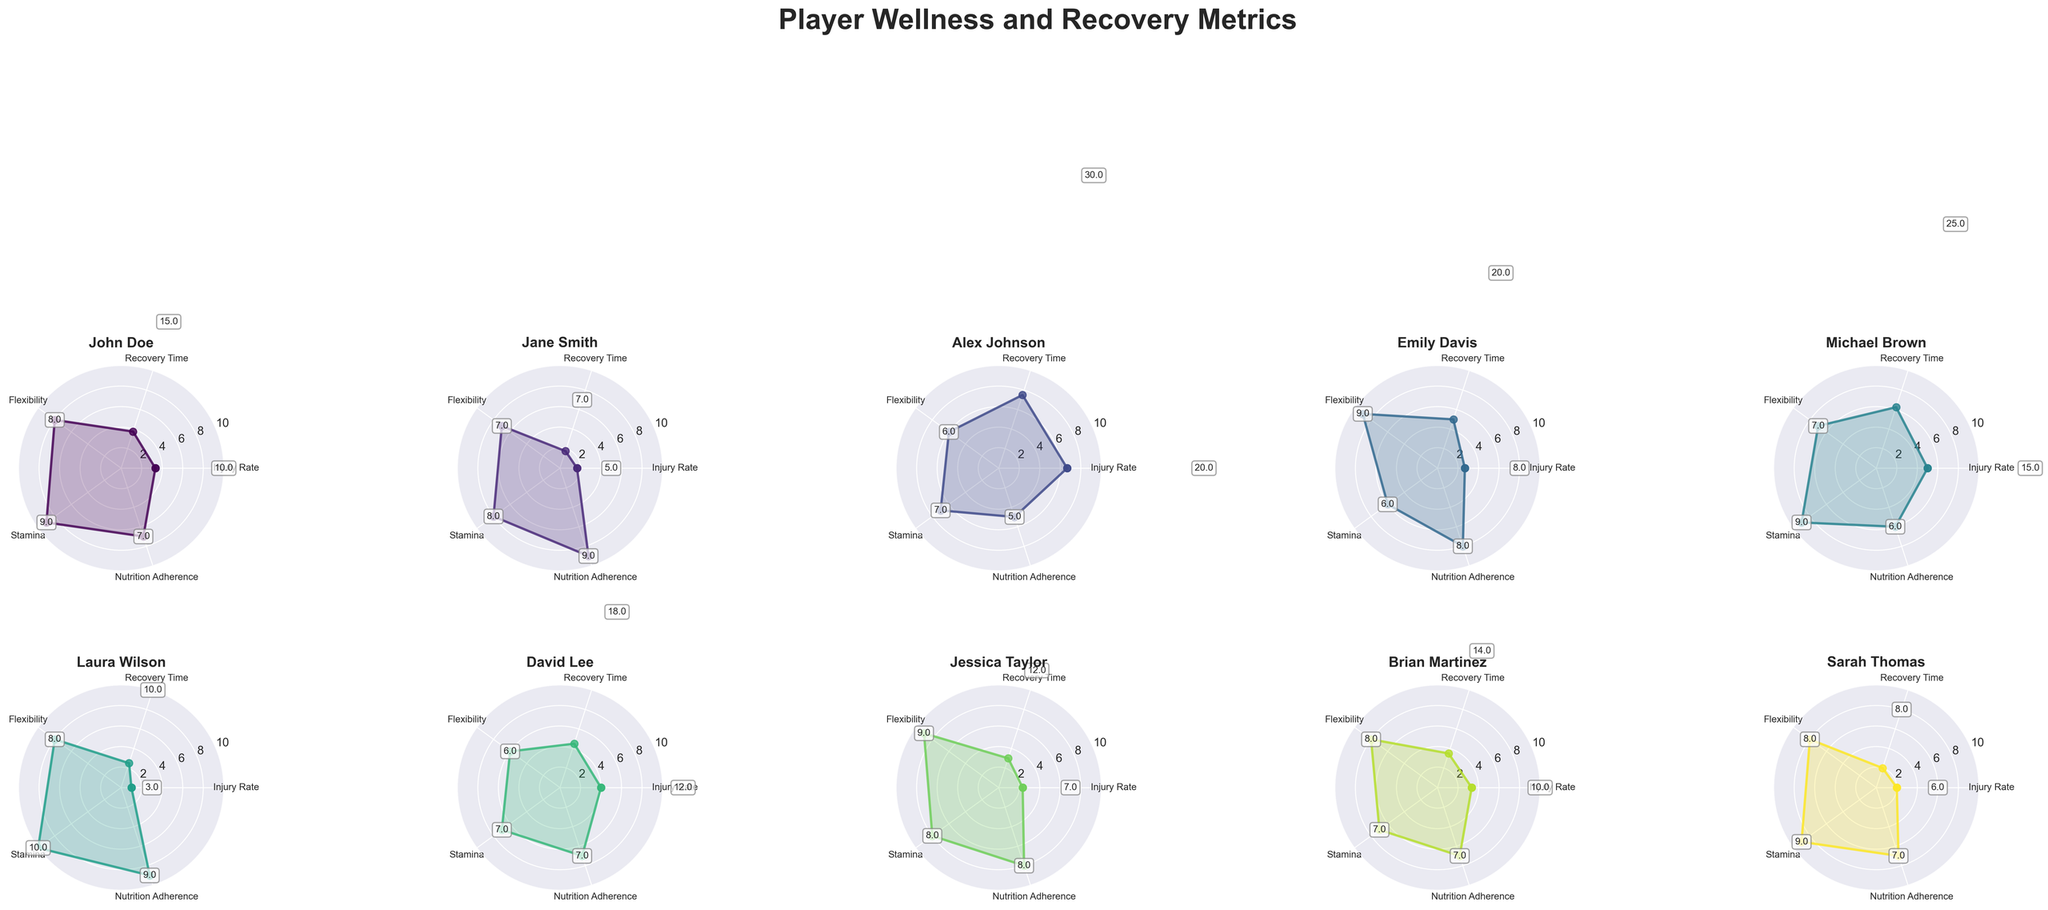Which player has the highest flexibility score? By looking at the radial coordinate representing flexibility on each radar chart, we can see that several players have flexibility scores of 8 and 9, with the highest being 9. Players with a flexibility score of 9 are Emily Davis and Jessica Taylor.
Answer: Emily Davis, Jessica Taylor What is the average stamina score of all players combined? The stamina scores are 9, 8, 7, 6, 9, 10, 7, 8, 7, 9. Adding these values gives 80. There are 10 players, so the average is 80/10.
Answer: 8 Which player has the lowest injury rate? By examining the radial coordinate for Injury Rate metric, the lowest percentage can be derived from Laura Wilson's chart, showing 3%.
Answer: Laura Wilson How many players have a nutrition adherence score of 9? By checking the Nutrition Adherence axis of each radar chart, the players with a score of 9 are Jane Smith, Laura Wilson, and Sarah Thomas.
Answer: 3 players Who has a higher recovery time: Michael Brown or David Lee? Check the Recovery Time radial coordinate for both players. Michael Brown has a recovery time of 25 days, while David Lee has a recovery time of 18 days, so Michael Brown's recovery time is higher.
Answer: Michael Brown What is the difference in stamina scores between Alex Johnson and Sarah Thomas? Alex Johnson has a stamina score of 7, while Sarah Thomas has a stamina score of 9. The difference is 9 - 7 = 2.
Answer: 2 Which player has the most balanced scores across all metrics? A balanced score would mean the scores are evenly spread out around the radar chart without extreme peaks or troughs. Laura Wilson has high scores that are relatively balanced across Injury Rate, Recovery Time, Flexibility, Stamina, and Nutrition Adherence.
Answer: Laura Wilson What is the combined flexibility score of all players? The flexibility scores are 8, 7, 6, 9, 7, 8, 6, 9, 8, 8. Adding these up gives 76.
Answer: 76 Who has better nutrition adherence, John Doe or Michael Brown? By examining the Nutrition Adherence radial coordinates for both players, John Doe has a score of 7, and Michael Brown has a score of 6. Therefore, John Doe's nutrition adherence is better.
Answer: John Doe 